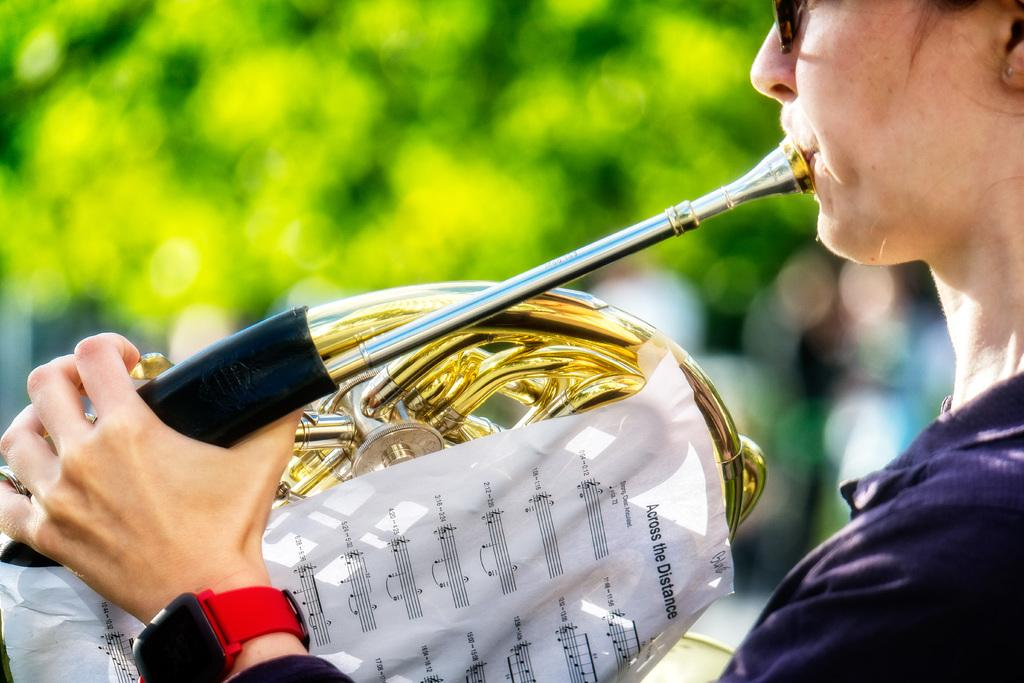<image>
Write a terse but informative summary of the picture. The top of the paper says across the distance 